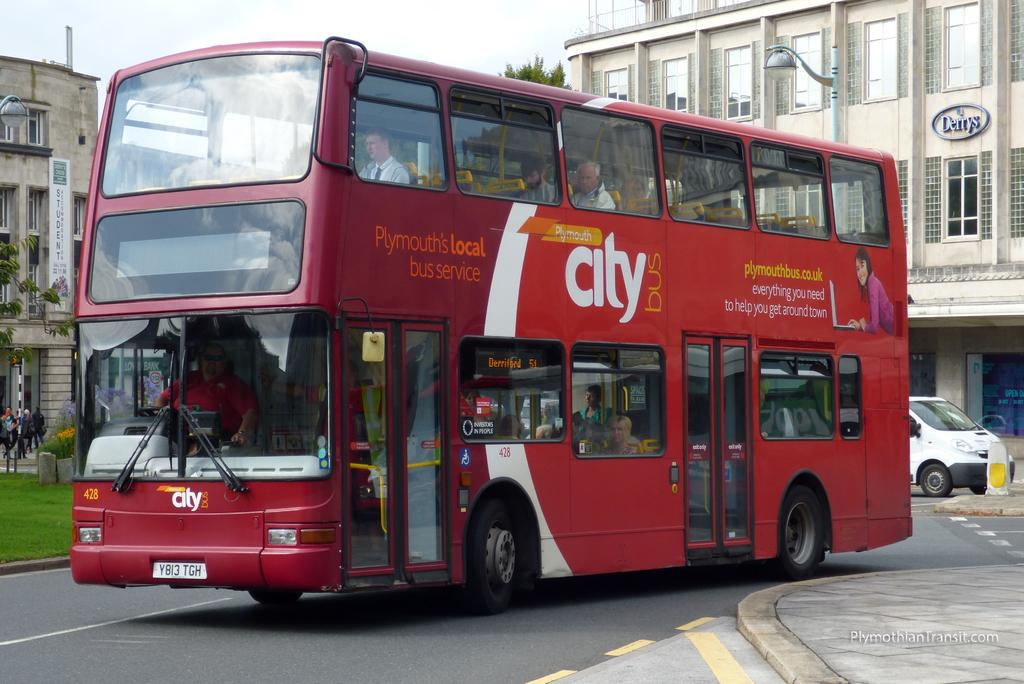What can be seen on the road in the image? There are vehicles on the road in the image. What is located to the left of the image? There is grass, a group of people, and a pole to the left of the image. What can be seen in the background of the image? There are buildings, trees, and the sky visible in the background of the image. What is the chance of the minister visiting the houses in the image? There is no mention of a minister or houses in the image, so it is not possible to determine the chance of the minister visiting the houses. 